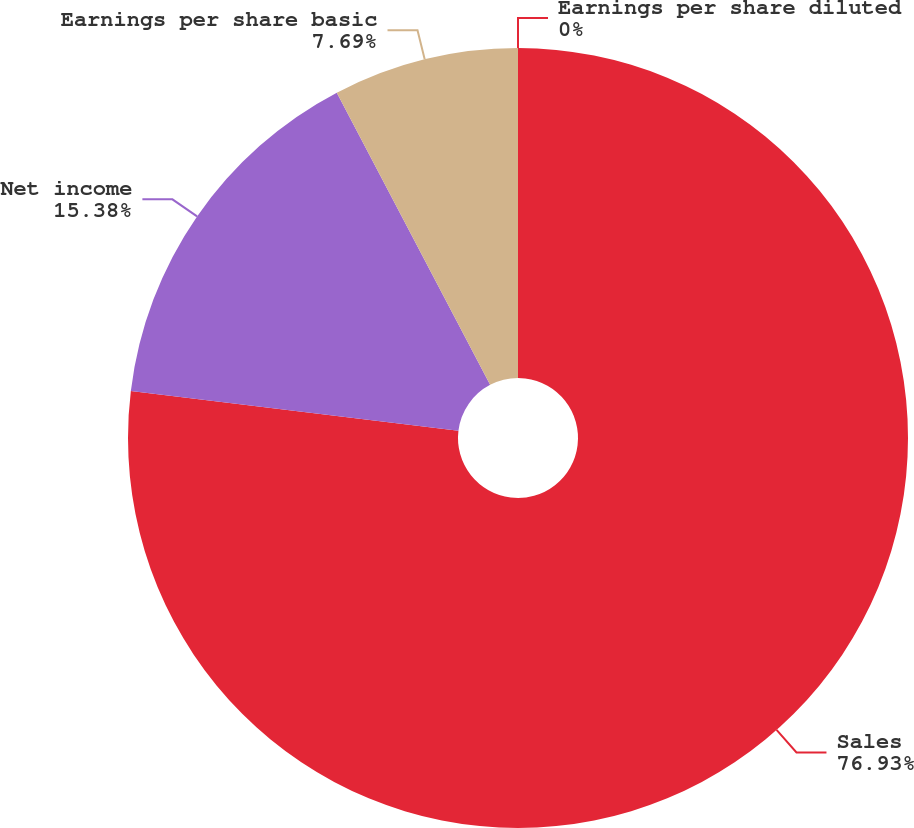Convert chart. <chart><loc_0><loc_0><loc_500><loc_500><pie_chart><fcel>Sales<fcel>Net income<fcel>Earnings per share basic<fcel>Earnings per share diluted<nl><fcel>76.92%<fcel>15.38%<fcel>7.69%<fcel>0.0%<nl></chart> 